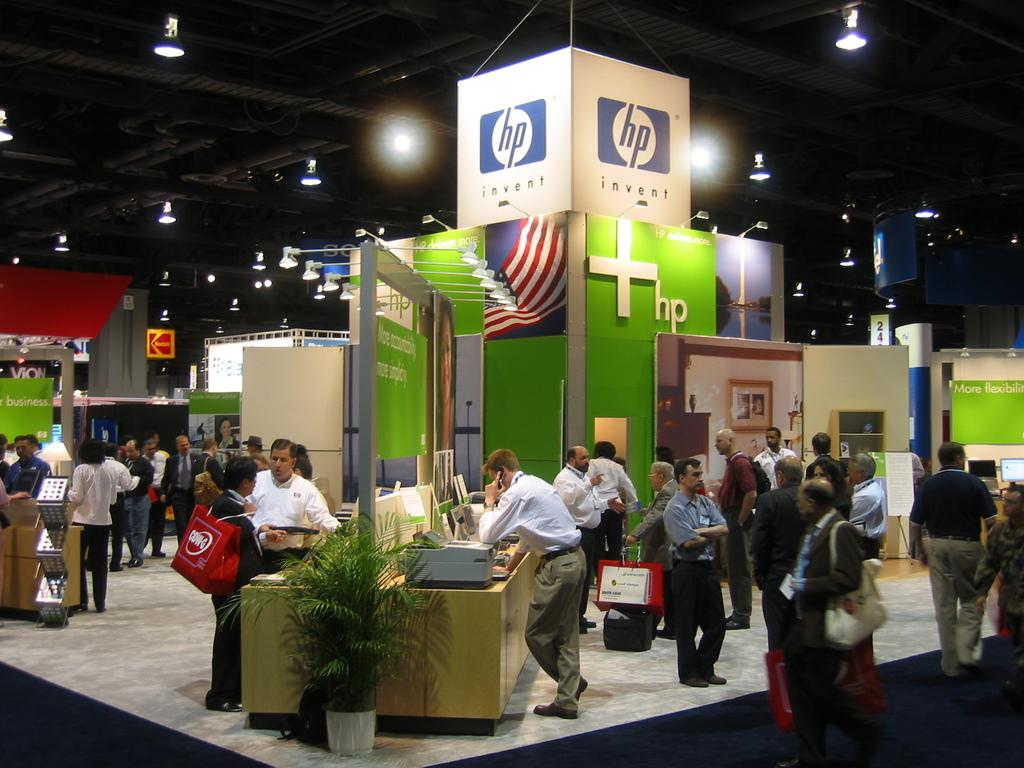What is located on top in the image? There are lights on top in the image. What are the people in the image doing? People are standing in the image. What type of structures can be seen in the image? There are stalls in the image. Can you describe the plant in the image? There is a plant in front of a table in the image. What objects are on the table in the image? There are devices on the table in the image. What is a person holding in the image? A person is holding a luggage in the image. What type of list can be seen on the table in the image? There is no list present on the table in the image. Can you tell me where the vein is located in the image? There is no mention of a vein in the image, as it is not a biological or medical context. 